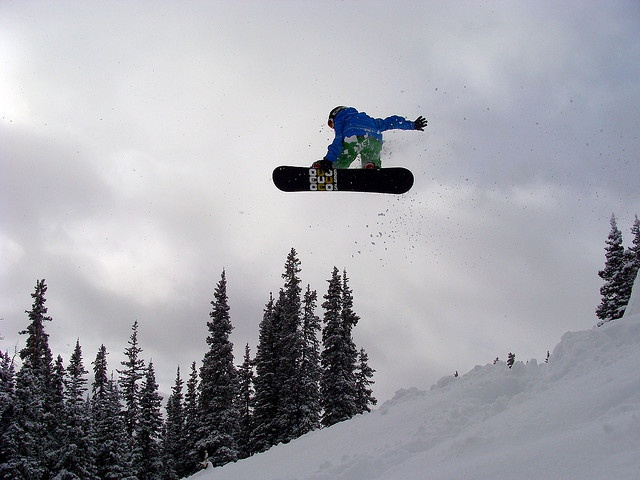Describe the objects in this image and their specific colors. I can see people in lavender, navy, black, gray, and darkgreen tones and snowboard in lavender, black, gray, darkgray, and lightgray tones in this image. 